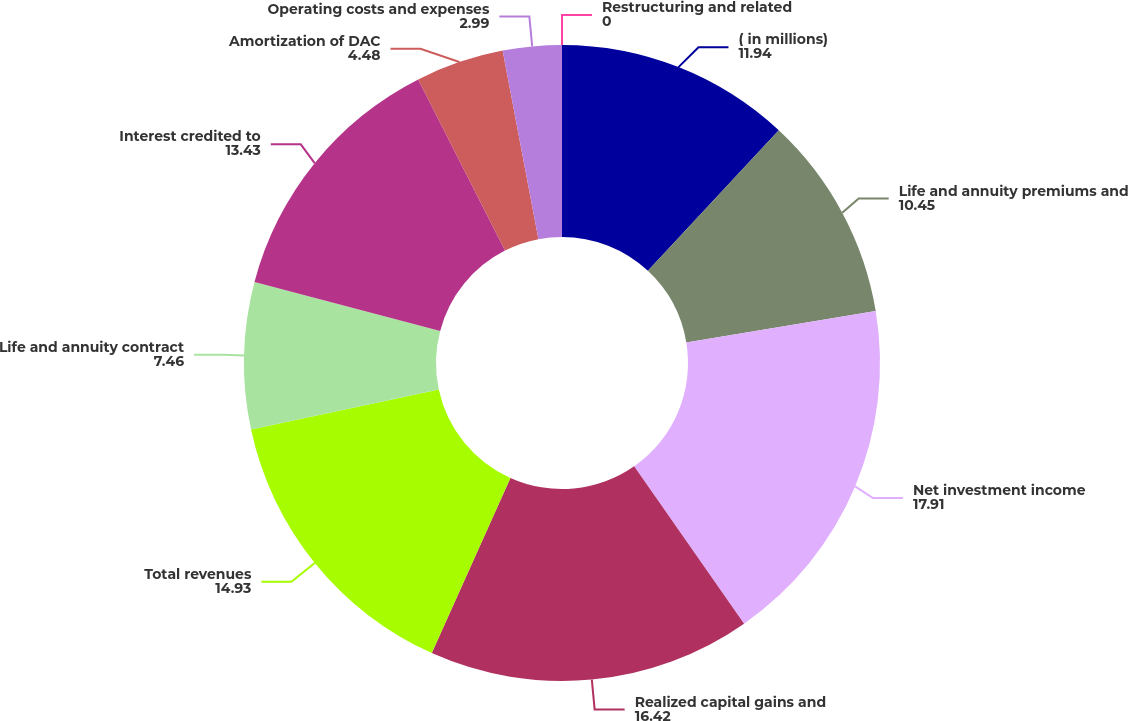Convert chart. <chart><loc_0><loc_0><loc_500><loc_500><pie_chart><fcel>( in millions)<fcel>Life and annuity premiums and<fcel>Net investment income<fcel>Realized capital gains and<fcel>Total revenues<fcel>Life and annuity contract<fcel>Interest credited to<fcel>Amortization of DAC<fcel>Operating costs and expenses<fcel>Restructuring and related<nl><fcel>11.94%<fcel>10.45%<fcel>17.91%<fcel>16.42%<fcel>14.93%<fcel>7.46%<fcel>13.43%<fcel>4.48%<fcel>2.99%<fcel>0.0%<nl></chart> 